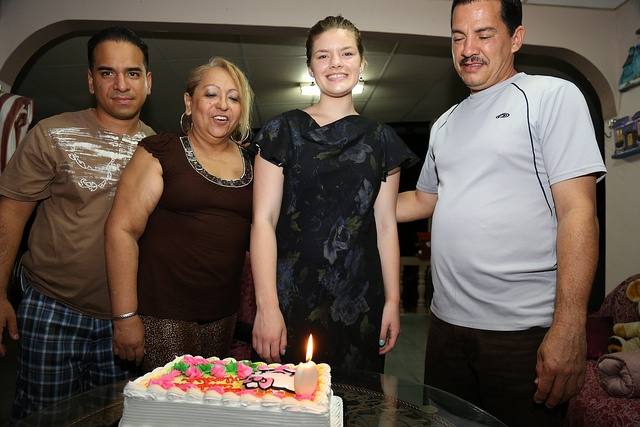Describe the objects in this image and their specific colors. I can see people in black, lightgray, darkgray, and gray tones, people in black, tan, and gray tones, people in black, maroon, and gray tones, people in black, gray, and maroon tones, and cake in black, darkgray, tan, beige, and lightpink tones in this image. 